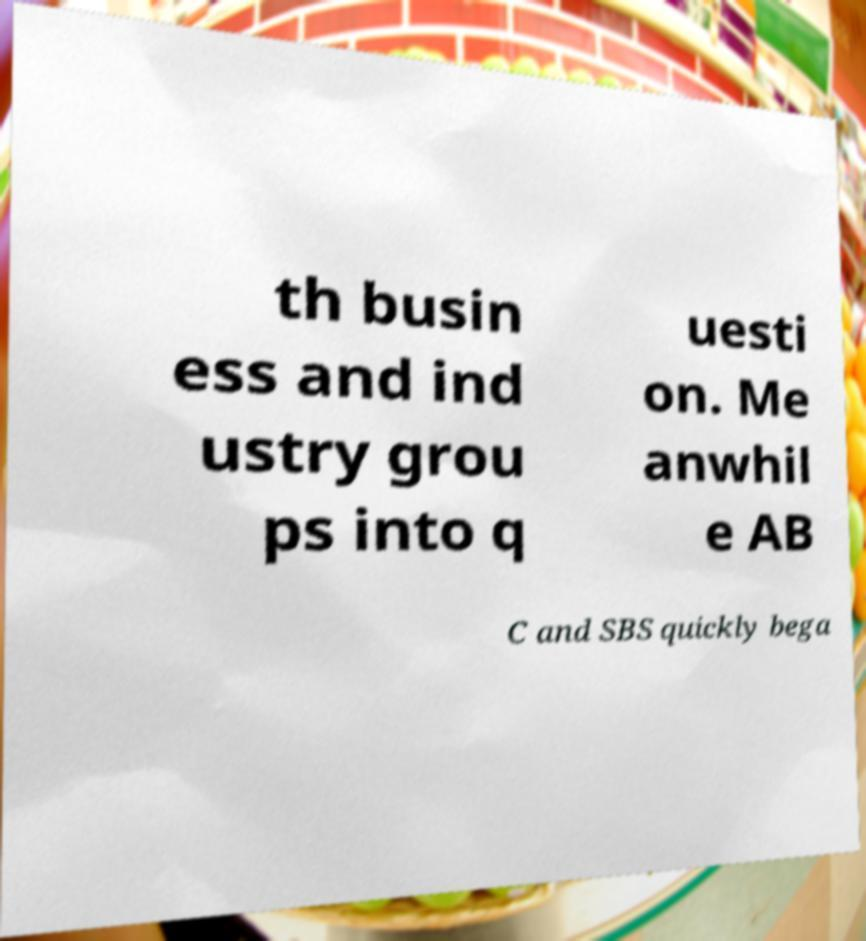Can you accurately transcribe the text from the provided image for me? th busin ess and ind ustry grou ps into q uesti on. Me anwhil e AB C and SBS quickly bega 